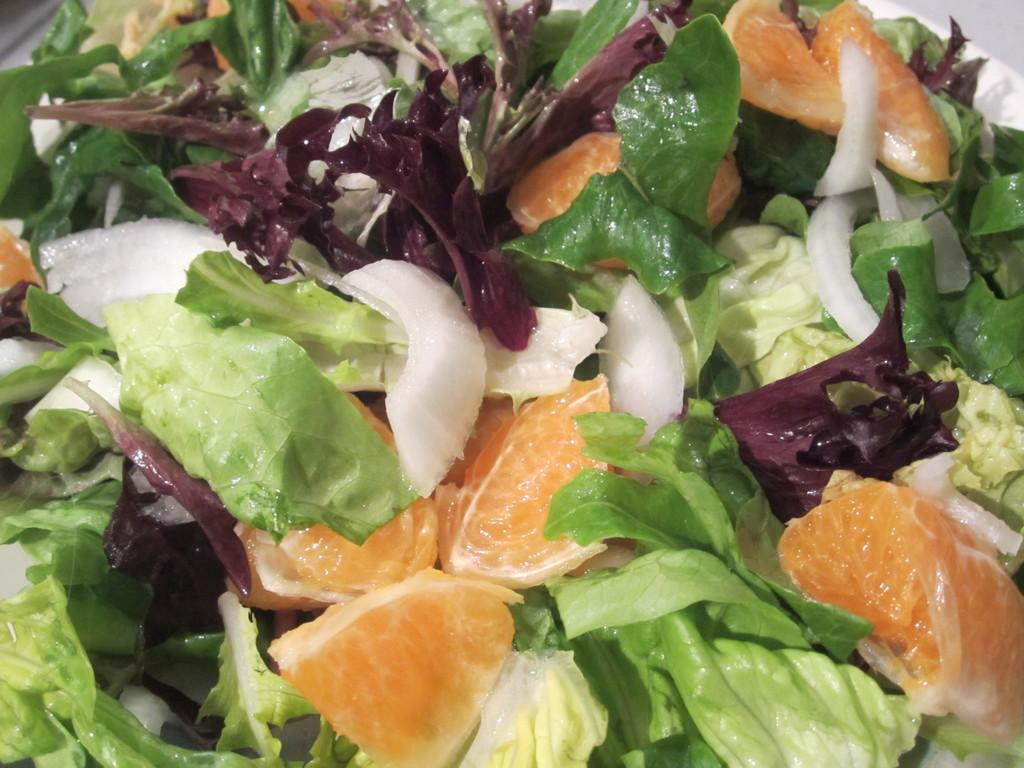What type of vegetable is present in the image? There is cabbage in the image. What fruit can be seen in the image? There is an orange in the image. What other vegetable is visible in the image? There is an onion in the image. What other food items are present in the image? There are other food items in a plate in the image. Where is the nest located in the image? There is no nest present in the image. What type of vase can be seen holding the cabbage in the image? There is no vase present in the image; the cabbage is not in a vase. 